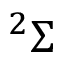<formula> <loc_0><loc_0><loc_500><loc_500>^ { 2 } \Sigma</formula> 